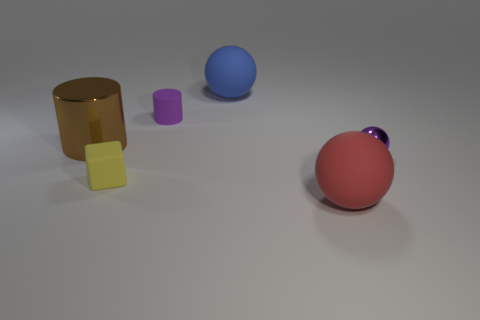Is the number of metal things that are to the left of the large red object greater than the number of cyan metallic balls?
Your response must be concise. Yes. What is the shape of the tiny thing that is the same color as the small shiny ball?
Your response must be concise. Cylinder. Are there any small purple objects made of the same material as the large blue sphere?
Provide a succinct answer. Yes. Is the material of the big object that is left of the small yellow rubber object the same as the ball that is in front of the small metallic sphere?
Keep it short and to the point. No. Are there an equal number of blue objects right of the purple metallic object and large cylinders that are in front of the block?
Keep it short and to the point. Yes. What is the color of the rubber cube that is the same size as the purple ball?
Make the answer very short. Yellow. Are there any large cylinders that have the same color as the tiny cylinder?
Provide a succinct answer. No. What number of objects are either big balls that are behind the tiny purple cylinder or blue matte spheres?
Keep it short and to the point. 1. What material is the tiny purple thing on the right side of the large matte ball behind the rubber sphere in front of the blue object made of?
Offer a terse response. Metal. How many cubes are either tiny yellow things or blue matte objects?
Give a very brief answer. 1. 